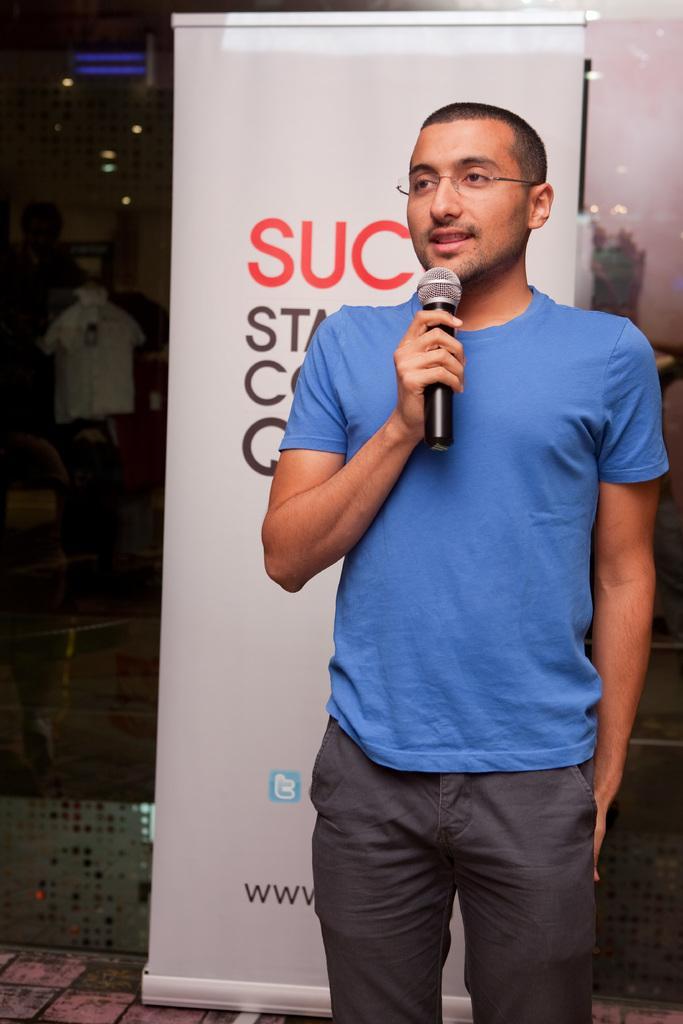Could you give a brief overview of what you see in this image? In the foreground of the image there is a person holding a mic. In the background of the image there is a white color banner with some text. There is a glass wall. At the bottom of the image there is floor. 